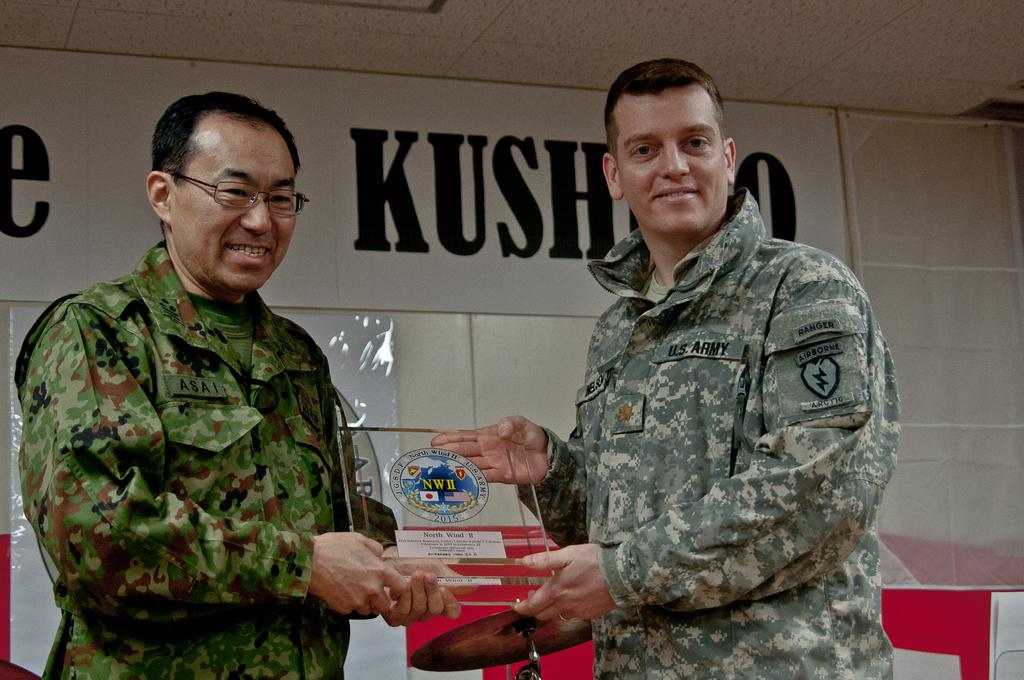How many people are in the image? There are two men in the image. What are the men doing in the image? The men are standing in the image. What are the men holding in the image? The men are holding an object in the image. What can be seen on the wall in the background of the image? There is a poster on the wall in the background of the image. What type of nail is being hammered into the wall by one of the men in the image? There is no nail or hammering activity present in the image. 